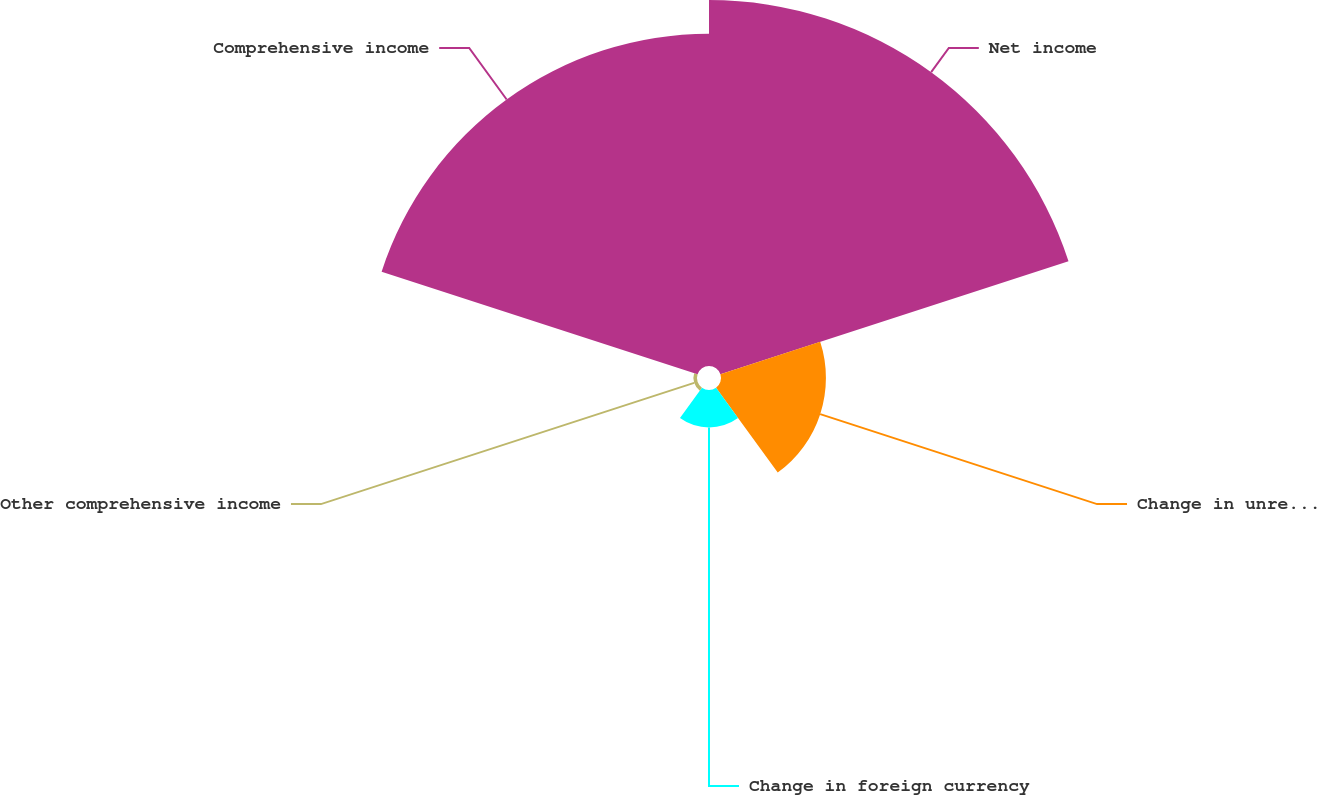Convert chart to OTSL. <chart><loc_0><loc_0><loc_500><loc_500><pie_chart><fcel>Net income<fcel>Change in unrealized gain on<fcel>Change in foreign currency<fcel>Other comprehensive income<fcel>Comprehensive income<nl><fcel>43.36%<fcel>12.43%<fcel>4.43%<fcel>0.43%<fcel>39.36%<nl></chart> 